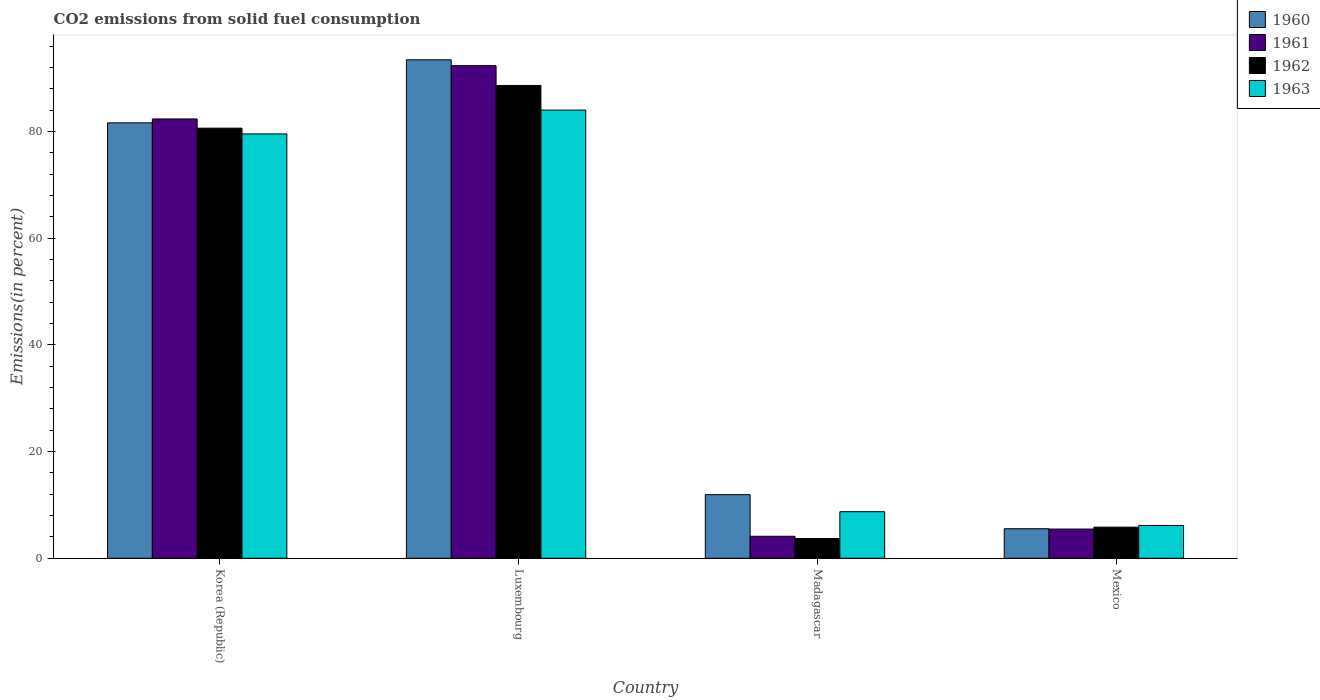In how many cases, is the number of bars for a given country not equal to the number of legend labels?
Keep it short and to the point. 0. What is the total CO2 emitted in 1963 in Luxembourg?
Your response must be concise. 84.02. Across all countries, what is the maximum total CO2 emitted in 1962?
Offer a very short reply. 88.63. Across all countries, what is the minimum total CO2 emitted in 1961?
Your response must be concise. 4.12. In which country was the total CO2 emitted in 1963 maximum?
Keep it short and to the point. Luxembourg. In which country was the total CO2 emitted in 1960 minimum?
Provide a short and direct response. Mexico. What is the total total CO2 emitted in 1961 in the graph?
Give a very brief answer. 184.3. What is the difference between the total CO2 emitted in 1961 in Luxembourg and that in Madagascar?
Provide a succinct answer. 88.22. What is the difference between the total CO2 emitted in 1962 in Madagascar and the total CO2 emitted in 1960 in Luxembourg?
Your answer should be compact. -89.74. What is the average total CO2 emitted in 1963 per country?
Your response must be concise. 44.61. What is the difference between the total CO2 emitted of/in 1963 and total CO2 emitted of/in 1960 in Mexico?
Provide a short and direct response. 0.61. What is the ratio of the total CO2 emitted in 1962 in Korea (Republic) to that in Luxembourg?
Your answer should be very brief. 0.91. What is the difference between the highest and the second highest total CO2 emitted in 1962?
Offer a very short reply. 8.01. What is the difference between the highest and the lowest total CO2 emitted in 1960?
Provide a short and direct response. 87.9. In how many countries, is the total CO2 emitted in 1961 greater than the average total CO2 emitted in 1961 taken over all countries?
Make the answer very short. 2. Is the sum of the total CO2 emitted in 1960 in Korea (Republic) and Madagascar greater than the maximum total CO2 emitted in 1963 across all countries?
Ensure brevity in your answer.  Yes. Is it the case that in every country, the sum of the total CO2 emitted in 1963 and total CO2 emitted in 1962 is greater than the sum of total CO2 emitted in 1961 and total CO2 emitted in 1960?
Provide a short and direct response. No. What does the 4th bar from the left in Madagascar represents?
Ensure brevity in your answer.  1963. What does the 3rd bar from the right in Korea (Republic) represents?
Provide a short and direct response. 1961. Is it the case that in every country, the sum of the total CO2 emitted in 1962 and total CO2 emitted in 1961 is greater than the total CO2 emitted in 1963?
Ensure brevity in your answer.  No. Are all the bars in the graph horizontal?
Your answer should be compact. No. What is the difference between two consecutive major ticks on the Y-axis?
Make the answer very short. 20. Are the values on the major ticks of Y-axis written in scientific E-notation?
Your response must be concise. No. Where does the legend appear in the graph?
Make the answer very short. Top right. How many legend labels are there?
Make the answer very short. 4. How are the legend labels stacked?
Your answer should be very brief. Vertical. What is the title of the graph?
Give a very brief answer. CO2 emissions from solid fuel consumption. Does "1977" appear as one of the legend labels in the graph?
Your answer should be very brief. No. What is the label or title of the X-axis?
Offer a terse response. Country. What is the label or title of the Y-axis?
Provide a succinct answer. Emissions(in percent). What is the Emissions(in percent) of 1960 in Korea (Republic)?
Your answer should be very brief. 81.62. What is the Emissions(in percent) of 1961 in Korea (Republic)?
Keep it short and to the point. 82.35. What is the Emissions(in percent) of 1962 in Korea (Republic)?
Offer a very short reply. 80.62. What is the Emissions(in percent) in 1963 in Korea (Republic)?
Offer a very short reply. 79.55. What is the Emissions(in percent) in 1960 in Luxembourg?
Provide a succinct answer. 93.44. What is the Emissions(in percent) in 1961 in Luxembourg?
Keep it short and to the point. 92.34. What is the Emissions(in percent) in 1962 in Luxembourg?
Your answer should be compact. 88.63. What is the Emissions(in percent) in 1963 in Luxembourg?
Your answer should be very brief. 84.02. What is the Emissions(in percent) of 1960 in Madagascar?
Your answer should be compact. 11.93. What is the Emissions(in percent) of 1961 in Madagascar?
Ensure brevity in your answer.  4.12. What is the Emissions(in percent) in 1962 in Madagascar?
Offer a terse response. 3.7. What is the Emissions(in percent) of 1963 in Madagascar?
Your response must be concise. 8.73. What is the Emissions(in percent) of 1960 in Mexico?
Your response must be concise. 5.54. What is the Emissions(in percent) of 1961 in Mexico?
Make the answer very short. 5.48. What is the Emissions(in percent) of 1962 in Mexico?
Keep it short and to the point. 5.83. What is the Emissions(in percent) in 1963 in Mexico?
Keep it short and to the point. 6.15. Across all countries, what is the maximum Emissions(in percent) in 1960?
Your response must be concise. 93.44. Across all countries, what is the maximum Emissions(in percent) in 1961?
Your answer should be compact. 92.34. Across all countries, what is the maximum Emissions(in percent) of 1962?
Ensure brevity in your answer.  88.63. Across all countries, what is the maximum Emissions(in percent) of 1963?
Give a very brief answer. 84.02. Across all countries, what is the minimum Emissions(in percent) in 1960?
Keep it short and to the point. 5.54. Across all countries, what is the minimum Emissions(in percent) of 1961?
Keep it short and to the point. 4.12. Across all countries, what is the minimum Emissions(in percent) in 1962?
Provide a short and direct response. 3.7. Across all countries, what is the minimum Emissions(in percent) of 1963?
Keep it short and to the point. 6.15. What is the total Emissions(in percent) of 1960 in the graph?
Ensure brevity in your answer.  192.53. What is the total Emissions(in percent) in 1961 in the graph?
Make the answer very short. 184.3. What is the total Emissions(in percent) of 1962 in the graph?
Provide a succinct answer. 178.8. What is the total Emissions(in percent) in 1963 in the graph?
Your answer should be very brief. 178.45. What is the difference between the Emissions(in percent) in 1960 in Korea (Republic) and that in Luxembourg?
Offer a terse response. -11.82. What is the difference between the Emissions(in percent) of 1961 in Korea (Republic) and that in Luxembourg?
Offer a terse response. -9.99. What is the difference between the Emissions(in percent) of 1962 in Korea (Republic) and that in Luxembourg?
Provide a succinct answer. -8.01. What is the difference between the Emissions(in percent) of 1963 in Korea (Republic) and that in Luxembourg?
Offer a very short reply. -4.47. What is the difference between the Emissions(in percent) in 1960 in Korea (Republic) and that in Madagascar?
Keep it short and to the point. 69.7. What is the difference between the Emissions(in percent) in 1961 in Korea (Republic) and that in Madagascar?
Provide a short and direct response. 78.23. What is the difference between the Emissions(in percent) of 1962 in Korea (Republic) and that in Madagascar?
Your answer should be compact. 76.92. What is the difference between the Emissions(in percent) in 1963 in Korea (Republic) and that in Madagascar?
Provide a succinct answer. 70.82. What is the difference between the Emissions(in percent) in 1960 in Korea (Republic) and that in Mexico?
Keep it short and to the point. 76.09. What is the difference between the Emissions(in percent) in 1961 in Korea (Republic) and that in Mexico?
Provide a succinct answer. 76.87. What is the difference between the Emissions(in percent) of 1962 in Korea (Republic) and that in Mexico?
Ensure brevity in your answer.  74.79. What is the difference between the Emissions(in percent) in 1963 in Korea (Republic) and that in Mexico?
Offer a terse response. 73.4. What is the difference between the Emissions(in percent) of 1960 in Luxembourg and that in Madagascar?
Provide a short and direct response. 81.52. What is the difference between the Emissions(in percent) in 1961 in Luxembourg and that in Madagascar?
Provide a succinct answer. 88.22. What is the difference between the Emissions(in percent) in 1962 in Luxembourg and that in Madagascar?
Make the answer very short. 84.93. What is the difference between the Emissions(in percent) of 1963 in Luxembourg and that in Madagascar?
Provide a succinct answer. 75.29. What is the difference between the Emissions(in percent) of 1960 in Luxembourg and that in Mexico?
Provide a succinct answer. 87.9. What is the difference between the Emissions(in percent) in 1961 in Luxembourg and that in Mexico?
Provide a succinct answer. 86.86. What is the difference between the Emissions(in percent) in 1962 in Luxembourg and that in Mexico?
Make the answer very short. 82.8. What is the difference between the Emissions(in percent) in 1963 in Luxembourg and that in Mexico?
Your answer should be compact. 77.87. What is the difference between the Emissions(in percent) in 1960 in Madagascar and that in Mexico?
Provide a succinct answer. 6.39. What is the difference between the Emissions(in percent) of 1961 in Madagascar and that in Mexico?
Make the answer very short. -1.36. What is the difference between the Emissions(in percent) of 1962 in Madagascar and that in Mexico?
Offer a very short reply. -2.13. What is the difference between the Emissions(in percent) of 1963 in Madagascar and that in Mexico?
Offer a terse response. 2.58. What is the difference between the Emissions(in percent) of 1960 in Korea (Republic) and the Emissions(in percent) of 1961 in Luxembourg?
Your answer should be compact. -10.72. What is the difference between the Emissions(in percent) of 1960 in Korea (Republic) and the Emissions(in percent) of 1962 in Luxembourg?
Your response must be concise. -7.01. What is the difference between the Emissions(in percent) of 1960 in Korea (Republic) and the Emissions(in percent) of 1963 in Luxembourg?
Keep it short and to the point. -2.39. What is the difference between the Emissions(in percent) of 1961 in Korea (Republic) and the Emissions(in percent) of 1962 in Luxembourg?
Keep it short and to the point. -6.28. What is the difference between the Emissions(in percent) in 1961 in Korea (Republic) and the Emissions(in percent) in 1963 in Luxembourg?
Provide a short and direct response. -1.66. What is the difference between the Emissions(in percent) in 1962 in Korea (Republic) and the Emissions(in percent) in 1963 in Luxembourg?
Provide a succinct answer. -3.39. What is the difference between the Emissions(in percent) in 1960 in Korea (Republic) and the Emissions(in percent) in 1961 in Madagascar?
Ensure brevity in your answer.  77.5. What is the difference between the Emissions(in percent) of 1960 in Korea (Republic) and the Emissions(in percent) of 1962 in Madagascar?
Your answer should be very brief. 77.92. What is the difference between the Emissions(in percent) in 1960 in Korea (Republic) and the Emissions(in percent) in 1963 in Madagascar?
Give a very brief answer. 72.89. What is the difference between the Emissions(in percent) in 1961 in Korea (Republic) and the Emissions(in percent) in 1962 in Madagascar?
Provide a short and direct response. 78.65. What is the difference between the Emissions(in percent) in 1961 in Korea (Republic) and the Emissions(in percent) in 1963 in Madagascar?
Your answer should be compact. 73.62. What is the difference between the Emissions(in percent) of 1962 in Korea (Republic) and the Emissions(in percent) of 1963 in Madagascar?
Offer a terse response. 71.89. What is the difference between the Emissions(in percent) of 1960 in Korea (Republic) and the Emissions(in percent) of 1961 in Mexico?
Offer a terse response. 76.14. What is the difference between the Emissions(in percent) in 1960 in Korea (Republic) and the Emissions(in percent) in 1962 in Mexico?
Keep it short and to the point. 75.79. What is the difference between the Emissions(in percent) of 1960 in Korea (Republic) and the Emissions(in percent) of 1963 in Mexico?
Make the answer very short. 75.47. What is the difference between the Emissions(in percent) in 1961 in Korea (Republic) and the Emissions(in percent) in 1962 in Mexico?
Provide a short and direct response. 76.52. What is the difference between the Emissions(in percent) in 1961 in Korea (Republic) and the Emissions(in percent) in 1963 in Mexico?
Provide a short and direct response. 76.2. What is the difference between the Emissions(in percent) of 1962 in Korea (Republic) and the Emissions(in percent) of 1963 in Mexico?
Offer a very short reply. 74.47. What is the difference between the Emissions(in percent) of 1960 in Luxembourg and the Emissions(in percent) of 1961 in Madagascar?
Your answer should be compact. 89.32. What is the difference between the Emissions(in percent) of 1960 in Luxembourg and the Emissions(in percent) of 1962 in Madagascar?
Offer a terse response. 89.74. What is the difference between the Emissions(in percent) in 1960 in Luxembourg and the Emissions(in percent) in 1963 in Madagascar?
Provide a succinct answer. 84.71. What is the difference between the Emissions(in percent) in 1961 in Luxembourg and the Emissions(in percent) in 1962 in Madagascar?
Ensure brevity in your answer.  88.64. What is the difference between the Emissions(in percent) of 1961 in Luxembourg and the Emissions(in percent) of 1963 in Madagascar?
Offer a very short reply. 83.61. What is the difference between the Emissions(in percent) in 1962 in Luxembourg and the Emissions(in percent) in 1963 in Madagascar?
Give a very brief answer. 79.9. What is the difference between the Emissions(in percent) in 1960 in Luxembourg and the Emissions(in percent) in 1961 in Mexico?
Ensure brevity in your answer.  87.96. What is the difference between the Emissions(in percent) in 1960 in Luxembourg and the Emissions(in percent) in 1962 in Mexico?
Your answer should be very brief. 87.61. What is the difference between the Emissions(in percent) in 1960 in Luxembourg and the Emissions(in percent) in 1963 in Mexico?
Your answer should be compact. 87.29. What is the difference between the Emissions(in percent) in 1961 in Luxembourg and the Emissions(in percent) in 1962 in Mexico?
Offer a terse response. 86.51. What is the difference between the Emissions(in percent) in 1961 in Luxembourg and the Emissions(in percent) in 1963 in Mexico?
Provide a short and direct response. 86.19. What is the difference between the Emissions(in percent) in 1962 in Luxembourg and the Emissions(in percent) in 1963 in Mexico?
Give a very brief answer. 82.48. What is the difference between the Emissions(in percent) in 1960 in Madagascar and the Emissions(in percent) in 1961 in Mexico?
Provide a short and direct response. 6.45. What is the difference between the Emissions(in percent) in 1960 in Madagascar and the Emissions(in percent) in 1962 in Mexico?
Ensure brevity in your answer.  6.09. What is the difference between the Emissions(in percent) of 1960 in Madagascar and the Emissions(in percent) of 1963 in Mexico?
Ensure brevity in your answer.  5.78. What is the difference between the Emissions(in percent) in 1961 in Madagascar and the Emissions(in percent) in 1962 in Mexico?
Keep it short and to the point. -1.71. What is the difference between the Emissions(in percent) in 1961 in Madagascar and the Emissions(in percent) in 1963 in Mexico?
Provide a succinct answer. -2.03. What is the difference between the Emissions(in percent) in 1962 in Madagascar and the Emissions(in percent) in 1963 in Mexico?
Your answer should be very brief. -2.45. What is the average Emissions(in percent) in 1960 per country?
Provide a succinct answer. 48.13. What is the average Emissions(in percent) in 1961 per country?
Provide a short and direct response. 46.08. What is the average Emissions(in percent) in 1962 per country?
Make the answer very short. 44.7. What is the average Emissions(in percent) in 1963 per country?
Your answer should be compact. 44.61. What is the difference between the Emissions(in percent) of 1960 and Emissions(in percent) of 1961 in Korea (Republic)?
Keep it short and to the point. -0.73. What is the difference between the Emissions(in percent) of 1960 and Emissions(in percent) of 1962 in Korea (Republic)?
Offer a terse response. 1. What is the difference between the Emissions(in percent) in 1960 and Emissions(in percent) in 1963 in Korea (Republic)?
Your answer should be very brief. 2.08. What is the difference between the Emissions(in percent) of 1961 and Emissions(in percent) of 1962 in Korea (Republic)?
Provide a short and direct response. 1.73. What is the difference between the Emissions(in percent) of 1961 and Emissions(in percent) of 1963 in Korea (Republic)?
Your answer should be compact. 2.8. What is the difference between the Emissions(in percent) of 1962 and Emissions(in percent) of 1963 in Korea (Republic)?
Offer a terse response. 1.08. What is the difference between the Emissions(in percent) of 1960 and Emissions(in percent) of 1961 in Luxembourg?
Offer a very short reply. 1.1. What is the difference between the Emissions(in percent) in 1960 and Emissions(in percent) in 1962 in Luxembourg?
Keep it short and to the point. 4.81. What is the difference between the Emissions(in percent) in 1960 and Emissions(in percent) in 1963 in Luxembourg?
Provide a succinct answer. 9.42. What is the difference between the Emissions(in percent) in 1961 and Emissions(in percent) in 1962 in Luxembourg?
Give a very brief answer. 3.71. What is the difference between the Emissions(in percent) in 1961 and Emissions(in percent) in 1963 in Luxembourg?
Provide a succinct answer. 8.33. What is the difference between the Emissions(in percent) in 1962 and Emissions(in percent) in 1963 in Luxembourg?
Provide a short and direct response. 4.62. What is the difference between the Emissions(in percent) of 1960 and Emissions(in percent) of 1961 in Madagascar?
Keep it short and to the point. 7.8. What is the difference between the Emissions(in percent) in 1960 and Emissions(in percent) in 1962 in Madagascar?
Your response must be concise. 8.22. What is the difference between the Emissions(in percent) of 1960 and Emissions(in percent) of 1963 in Madagascar?
Ensure brevity in your answer.  3.2. What is the difference between the Emissions(in percent) in 1961 and Emissions(in percent) in 1962 in Madagascar?
Provide a succinct answer. 0.42. What is the difference between the Emissions(in percent) in 1961 and Emissions(in percent) in 1963 in Madagascar?
Offer a terse response. -4.61. What is the difference between the Emissions(in percent) in 1962 and Emissions(in percent) in 1963 in Madagascar?
Provide a short and direct response. -5.03. What is the difference between the Emissions(in percent) of 1960 and Emissions(in percent) of 1961 in Mexico?
Your response must be concise. 0.06. What is the difference between the Emissions(in percent) in 1960 and Emissions(in percent) in 1962 in Mexico?
Keep it short and to the point. -0.3. What is the difference between the Emissions(in percent) of 1960 and Emissions(in percent) of 1963 in Mexico?
Your response must be concise. -0.61. What is the difference between the Emissions(in percent) of 1961 and Emissions(in percent) of 1962 in Mexico?
Provide a short and direct response. -0.35. What is the difference between the Emissions(in percent) of 1961 and Emissions(in percent) of 1963 in Mexico?
Ensure brevity in your answer.  -0.67. What is the difference between the Emissions(in percent) of 1962 and Emissions(in percent) of 1963 in Mexico?
Your answer should be compact. -0.32. What is the ratio of the Emissions(in percent) of 1960 in Korea (Republic) to that in Luxembourg?
Keep it short and to the point. 0.87. What is the ratio of the Emissions(in percent) in 1961 in Korea (Republic) to that in Luxembourg?
Keep it short and to the point. 0.89. What is the ratio of the Emissions(in percent) of 1962 in Korea (Republic) to that in Luxembourg?
Offer a very short reply. 0.91. What is the ratio of the Emissions(in percent) in 1963 in Korea (Republic) to that in Luxembourg?
Provide a short and direct response. 0.95. What is the ratio of the Emissions(in percent) of 1960 in Korea (Republic) to that in Madagascar?
Your answer should be compact. 6.84. What is the ratio of the Emissions(in percent) in 1961 in Korea (Republic) to that in Madagascar?
Your answer should be compact. 19.97. What is the ratio of the Emissions(in percent) in 1962 in Korea (Republic) to that in Madagascar?
Your answer should be compact. 21.77. What is the ratio of the Emissions(in percent) in 1963 in Korea (Republic) to that in Madagascar?
Your response must be concise. 9.11. What is the ratio of the Emissions(in percent) of 1960 in Korea (Republic) to that in Mexico?
Your response must be concise. 14.74. What is the ratio of the Emissions(in percent) of 1961 in Korea (Republic) to that in Mexico?
Your response must be concise. 15.03. What is the ratio of the Emissions(in percent) of 1962 in Korea (Republic) to that in Mexico?
Keep it short and to the point. 13.82. What is the ratio of the Emissions(in percent) in 1963 in Korea (Republic) to that in Mexico?
Ensure brevity in your answer.  12.93. What is the ratio of the Emissions(in percent) in 1960 in Luxembourg to that in Madagascar?
Offer a terse response. 7.83. What is the ratio of the Emissions(in percent) of 1961 in Luxembourg to that in Madagascar?
Your response must be concise. 22.39. What is the ratio of the Emissions(in percent) in 1962 in Luxembourg to that in Madagascar?
Keep it short and to the point. 23.93. What is the ratio of the Emissions(in percent) in 1963 in Luxembourg to that in Madagascar?
Your answer should be very brief. 9.62. What is the ratio of the Emissions(in percent) of 1960 in Luxembourg to that in Mexico?
Your answer should be compact. 16.88. What is the ratio of the Emissions(in percent) of 1961 in Luxembourg to that in Mexico?
Provide a succinct answer. 16.85. What is the ratio of the Emissions(in percent) of 1962 in Luxembourg to that in Mexico?
Provide a succinct answer. 15.2. What is the ratio of the Emissions(in percent) in 1963 in Luxembourg to that in Mexico?
Your response must be concise. 13.66. What is the ratio of the Emissions(in percent) of 1960 in Madagascar to that in Mexico?
Make the answer very short. 2.15. What is the ratio of the Emissions(in percent) in 1961 in Madagascar to that in Mexico?
Offer a terse response. 0.75. What is the ratio of the Emissions(in percent) in 1962 in Madagascar to that in Mexico?
Offer a terse response. 0.64. What is the ratio of the Emissions(in percent) of 1963 in Madagascar to that in Mexico?
Offer a very short reply. 1.42. What is the difference between the highest and the second highest Emissions(in percent) of 1960?
Your answer should be very brief. 11.82. What is the difference between the highest and the second highest Emissions(in percent) of 1961?
Offer a very short reply. 9.99. What is the difference between the highest and the second highest Emissions(in percent) in 1962?
Provide a short and direct response. 8.01. What is the difference between the highest and the second highest Emissions(in percent) in 1963?
Offer a very short reply. 4.47. What is the difference between the highest and the lowest Emissions(in percent) of 1960?
Your answer should be compact. 87.9. What is the difference between the highest and the lowest Emissions(in percent) in 1961?
Your response must be concise. 88.22. What is the difference between the highest and the lowest Emissions(in percent) in 1962?
Provide a succinct answer. 84.93. What is the difference between the highest and the lowest Emissions(in percent) of 1963?
Your response must be concise. 77.87. 